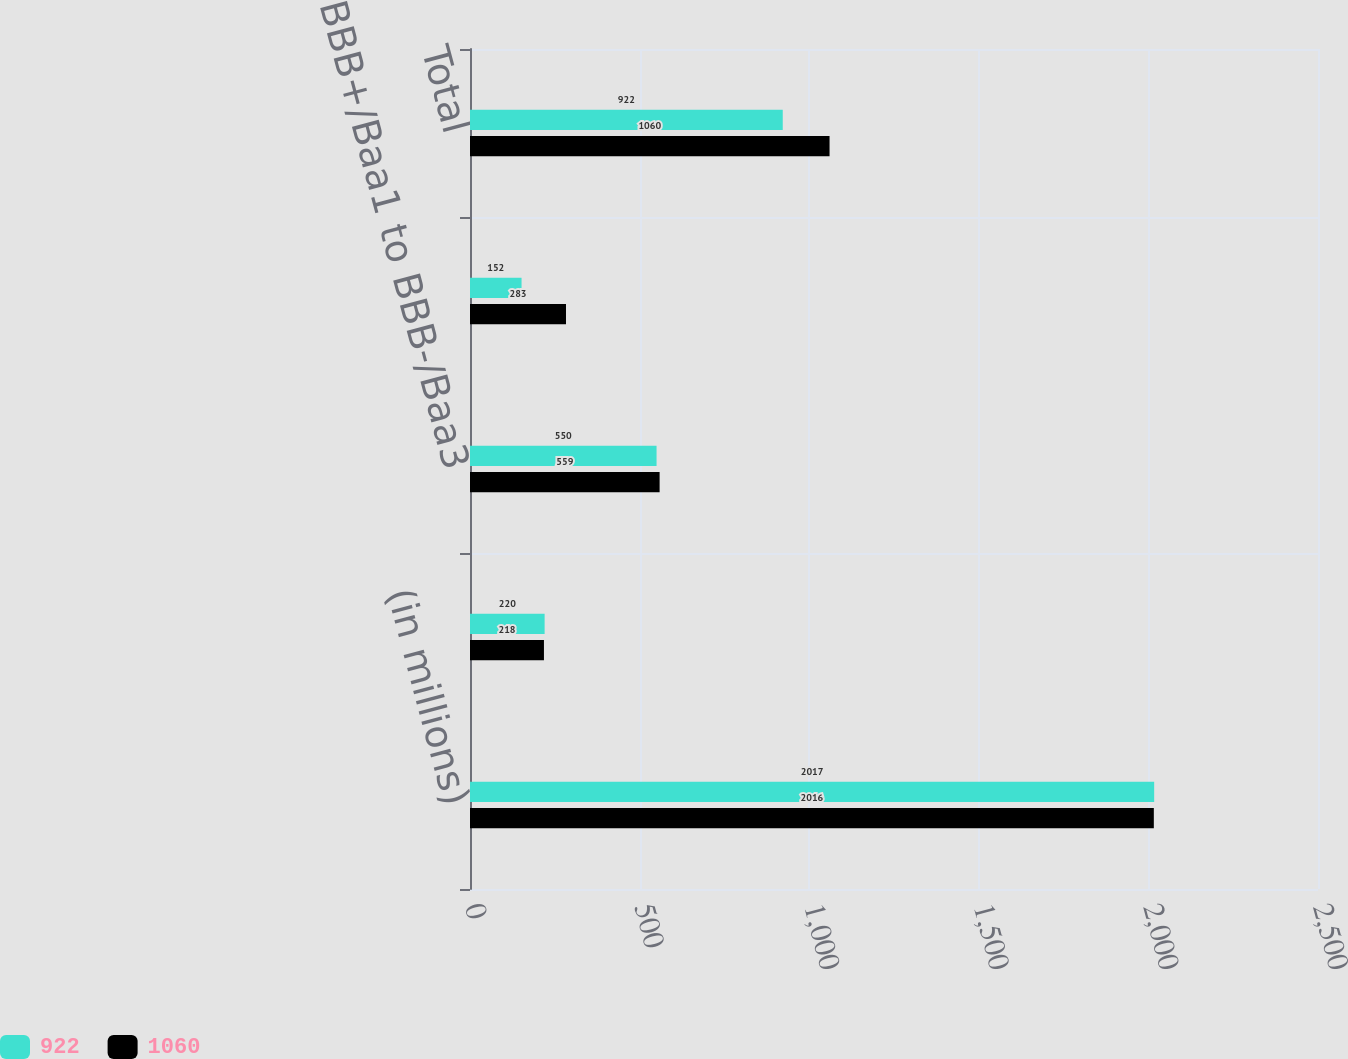Convert chart to OTSL. <chart><loc_0><loc_0><loc_500><loc_500><stacked_bar_chart><ecel><fcel>(in millions)<fcel>Credit Rating by Standard &<fcel>BBB+/Baa1 to BBB-/Baa3<fcel>BB+/Ba1 and Lower<fcel>Total<nl><fcel>922<fcel>2017<fcel>220<fcel>550<fcel>152<fcel>922<nl><fcel>1060<fcel>2016<fcel>218<fcel>559<fcel>283<fcel>1060<nl></chart> 